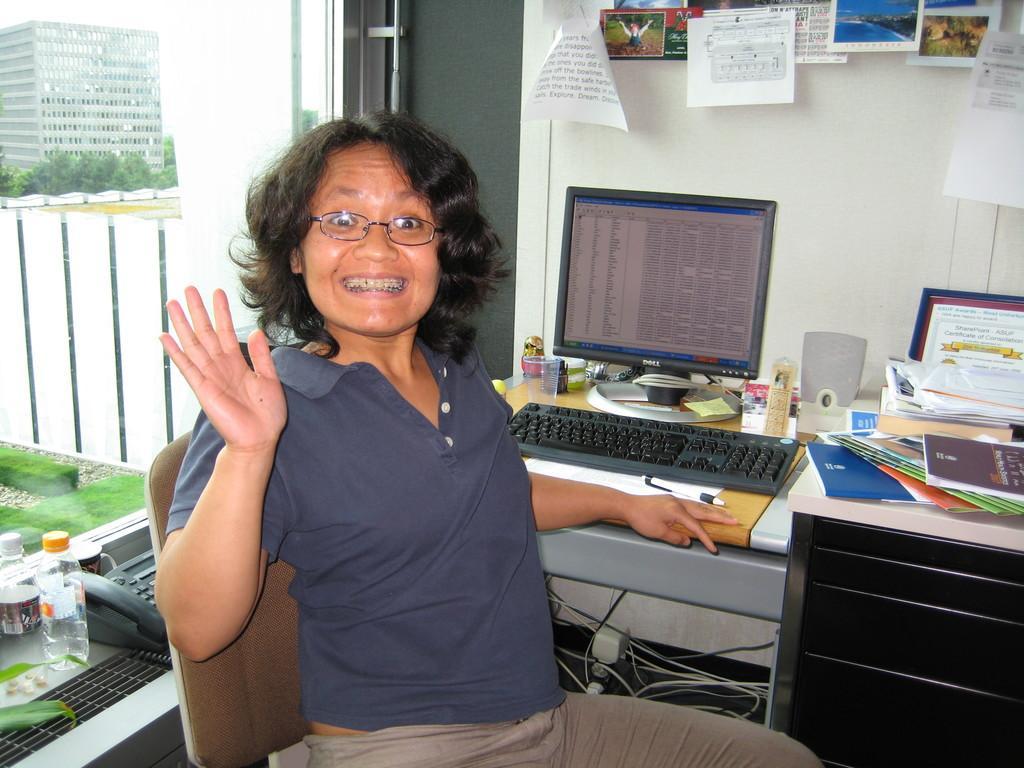Can you describe this image briefly? In this image, we can see a woman sitting on a chair, we can see a table, on that table, we can see a keyboard and a monitor, we can see some objects on the table, on the left side we can see a telephone and we can see a window. 